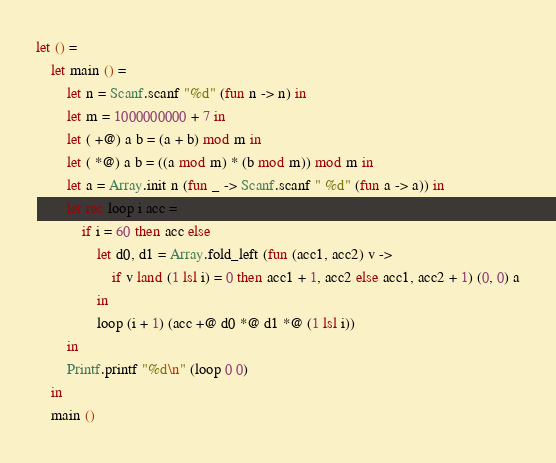<code> <loc_0><loc_0><loc_500><loc_500><_OCaml_>let () =
    let main () =
        let n = Scanf.scanf "%d" (fun n -> n) in
        let m = 1000000000 + 7 in
        let ( +@) a b = (a + b) mod m in
        let ( *@) a b = ((a mod m) * (b mod m)) mod m in
        let a = Array.init n (fun _ -> Scanf.scanf " %d" (fun a -> a)) in
        let rec loop i acc =
            if i = 60 then acc else
                let d0, d1 = Array.fold_left (fun (acc1, acc2) v ->
                    if v land (1 lsl i) = 0 then acc1 + 1, acc2 else acc1, acc2 + 1) (0, 0) a
                in
                loop (i + 1) (acc +@ d0 *@ d1 *@ (1 lsl i))
        in
        Printf.printf "%d\n" (loop 0 0)
    in
    main ()</code> 